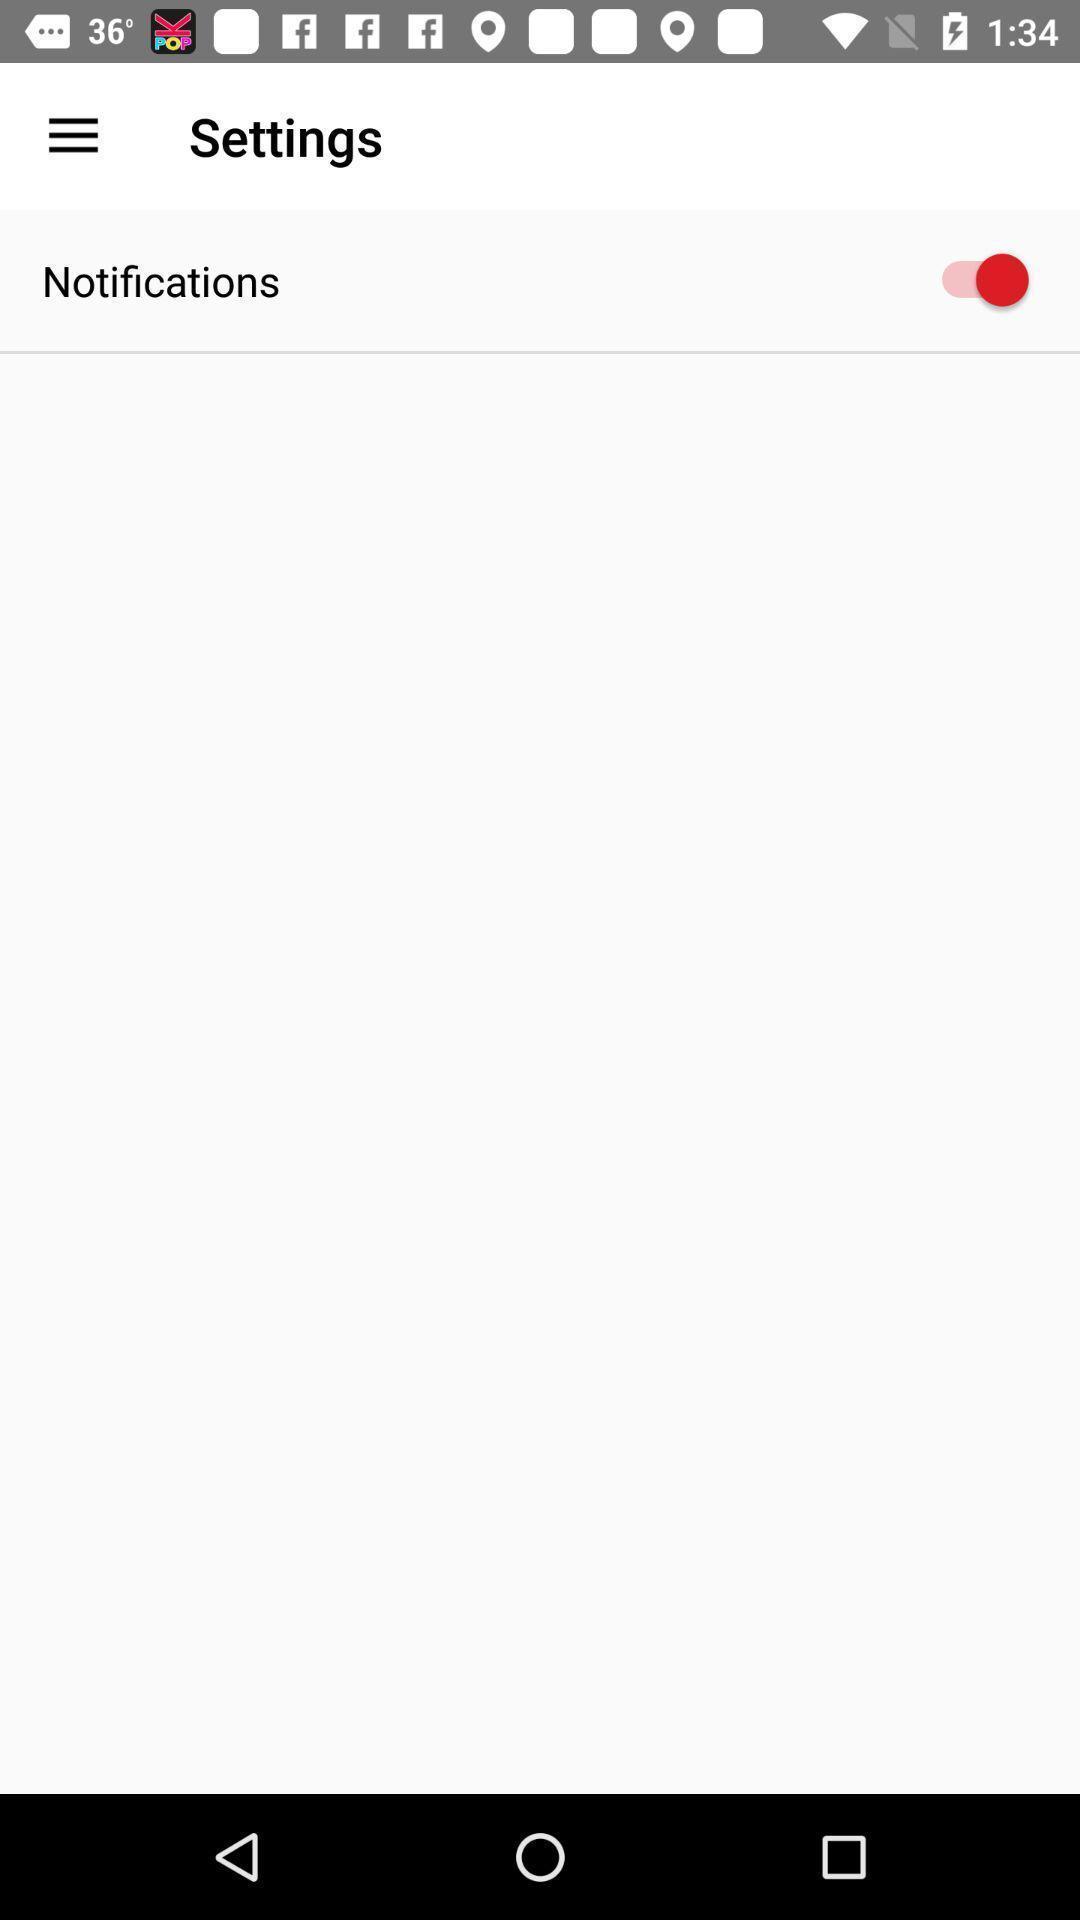What is the overall content of this screenshot? Screen shows settings. 